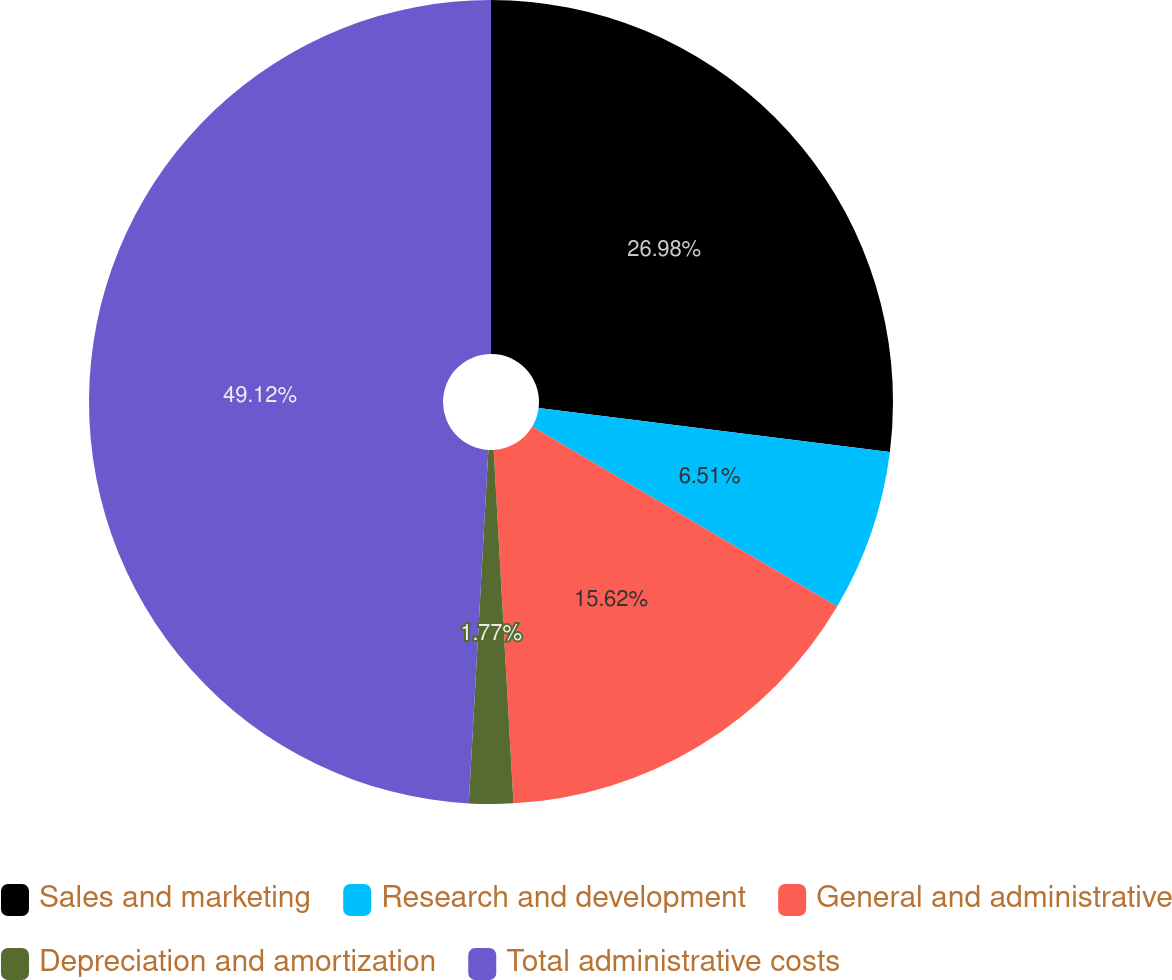<chart> <loc_0><loc_0><loc_500><loc_500><pie_chart><fcel>Sales and marketing<fcel>Research and development<fcel>General and administrative<fcel>Depreciation and amortization<fcel>Total administrative costs<nl><fcel>26.98%<fcel>6.51%<fcel>15.62%<fcel>1.77%<fcel>49.12%<nl></chart> 